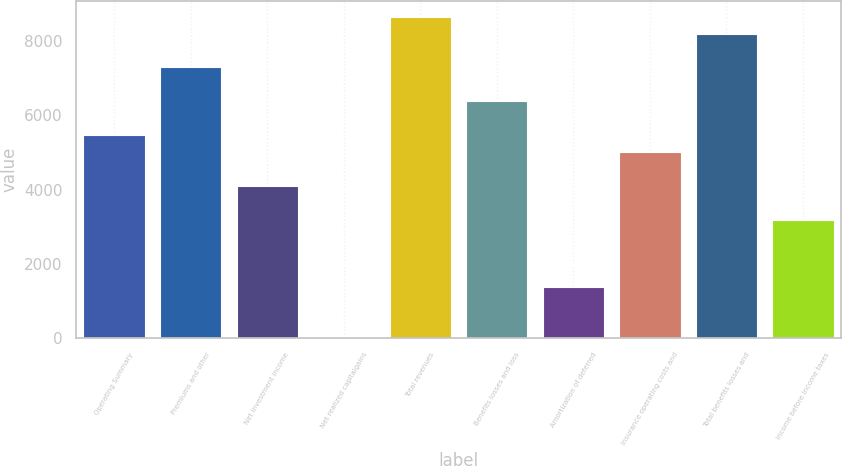Convert chart to OTSL. <chart><loc_0><loc_0><loc_500><loc_500><bar_chart><fcel>Operating Summary<fcel>Premiums and other<fcel>Net investment income<fcel>Net realized capitalgains<fcel>Total revenues<fcel>Benefits losses and loss<fcel>Amortization of deferred<fcel>Insurance operating costs and<fcel>Total benefits losses and<fcel>Income before income taxes<nl><fcel>5465.4<fcel>7286.2<fcel>4099.8<fcel>3<fcel>8651.8<fcel>6375.8<fcel>1368.6<fcel>5010.2<fcel>8196.6<fcel>3189.4<nl></chart> 